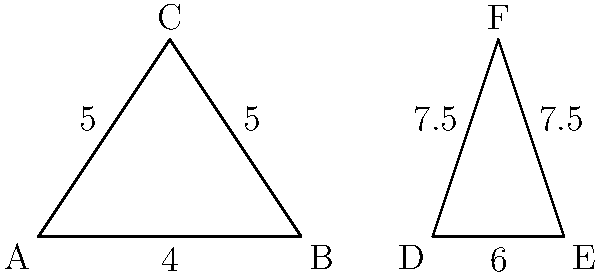Looking at Mount Pilchuck and Mount Index from Snohomish County, you notice their shapes are similar. If the base of Mount Pilchuck (triangle ABC) is 4 units wide and its sides are 5 units long, while the base of Mount Index (triangle DEF) is 6 units wide, what is the length of Mount Index's sides? Let's approach this step-by-step:

1) First, we need to recognize that the two triangles are similar, as stated in the question.

2) In similar triangles, the ratio of corresponding sides is constant. Let's call this ratio $r$.

3) We can find $r$ by comparing the bases of the two triangles:
   $r = \frac{\text{base of DEF}}{\text{base of ABC}} = \frac{6}{4} = 1.5$

4) Now, we can use this ratio to find the length of the sides of triangle DEF:
   $\text{side of DEF} = r \times \text{side of ABC}$

5) We know the side of ABC is 5 units, so:
   $\text{side of DEF} = 1.5 \times 5 = 7.5$ units

Therefore, the sides of Mount Index (triangle DEF) are 7.5 units long.
Answer: 7.5 units 